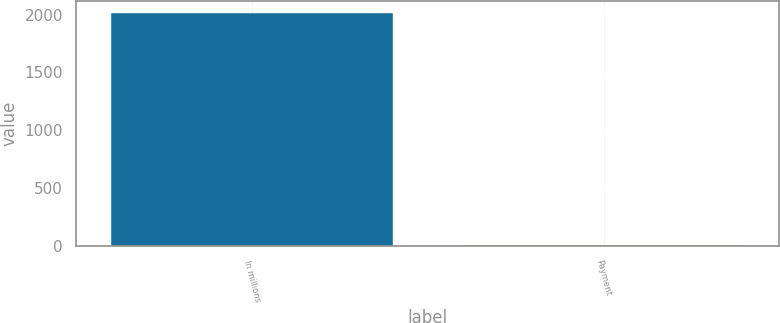<chart> <loc_0><loc_0><loc_500><loc_500><bar_chart><fcel>In millions<fcel>Payment<nl><fcel>2017<fcel>8<nl></chart> 